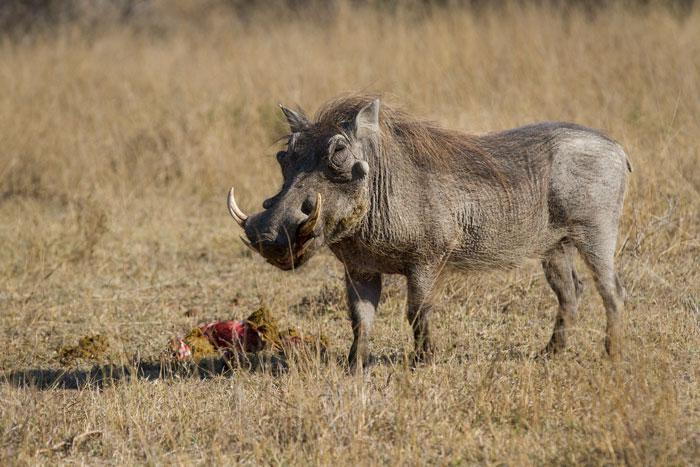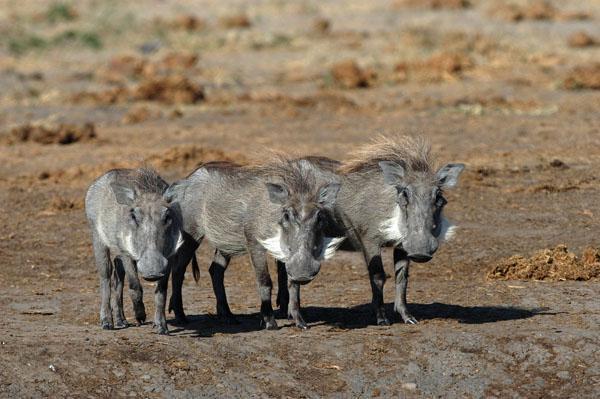The first image is the image on the left, the second image is the image on the right. Considering the images on both sides, is "An image with a row of at least three warthogs includes at least one that looks straight at the camera." valid? Answer yes or no. Yes. The first image is the image on the left, the second image is the image on the right. Assess this claim about the two images: "There's exactly two warthogs in the left image.". Correct or not? Answer yes or no. No. 